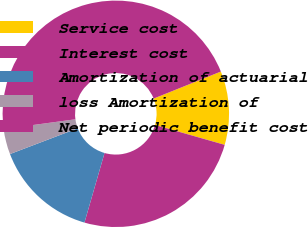Convert chart. <chart><loc_0><loc_0><loc_500><loc_500><pie_chart><fcel>Service cost<fcel>Interest cost<fcel>Amortization of actuarial<fcel>loss Amortization of<fcel>Net periodic benefit cost<nl><fcel>10.51%<fcel>25.05%<fcel>14.75%<fcel>3.64%<fcel>46.06%<nl></chart> 